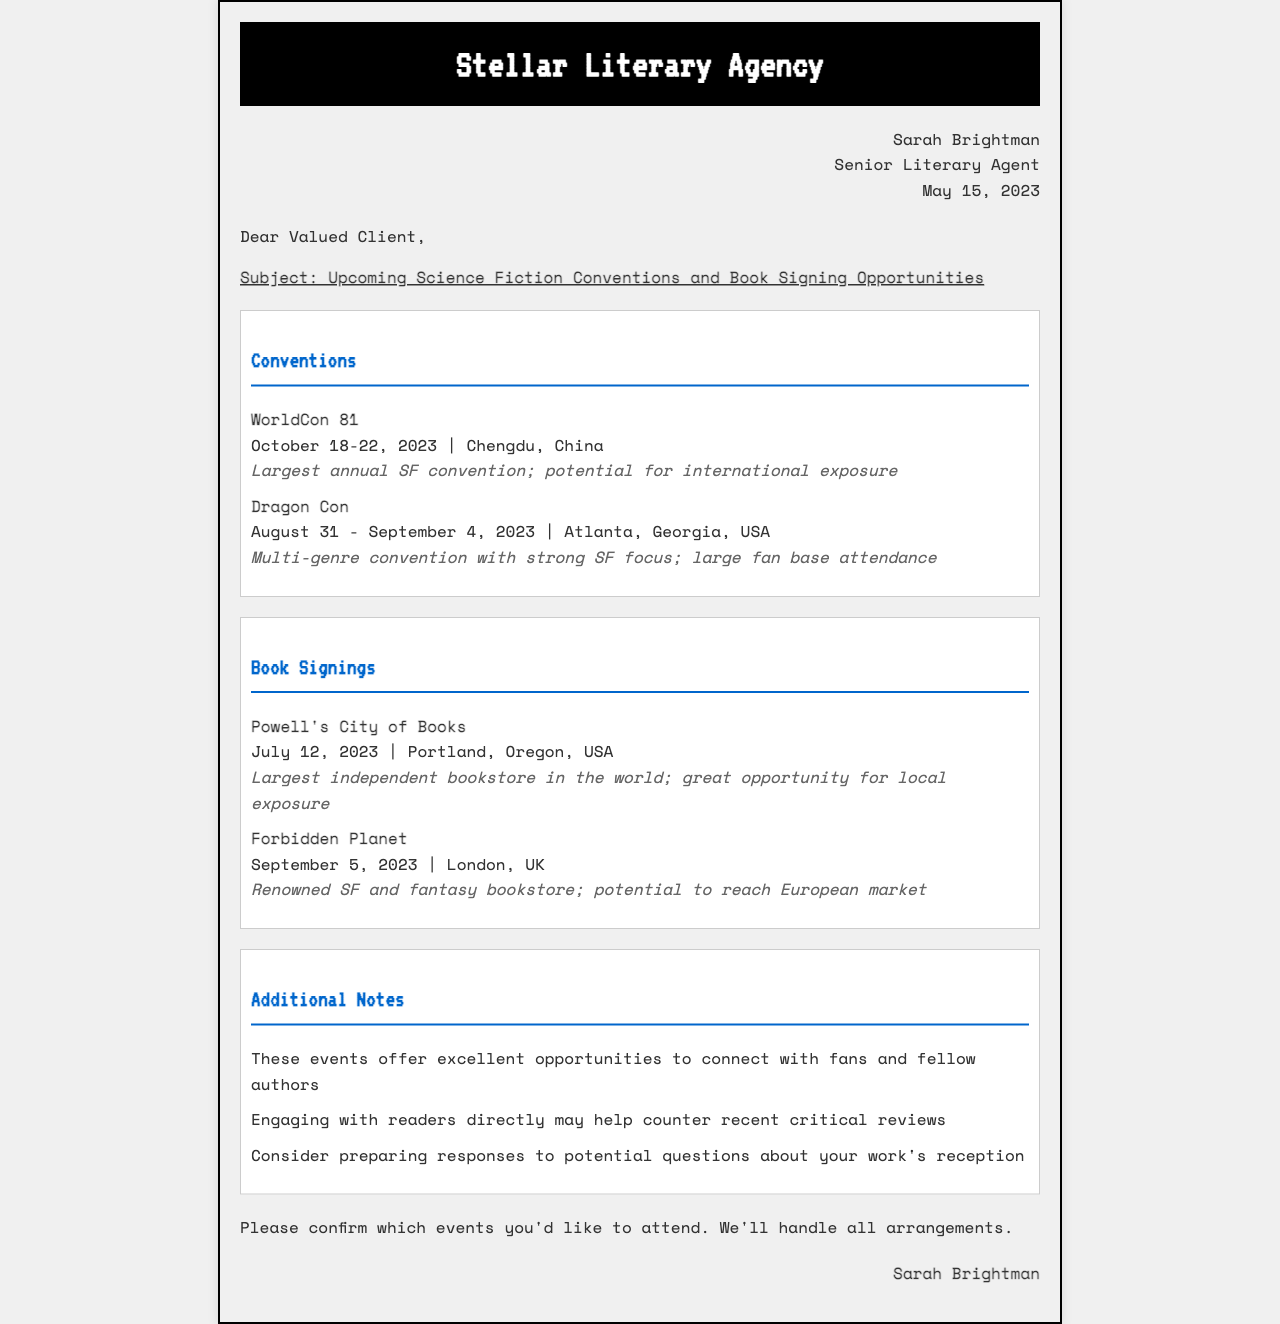What is the name of the literary agency? The name of the literary agency is mentioned in the header of the document.
Answer: Stellar Literary Agency Who is the agent that sent this fax? The agent's name is listed in the agent information section of the document.
Answer: Sarah Brightman When is WorldCon 81 taking place? The date for WorldCon 81 is provided in the conventions section of the document.
Answer: October 18-22, 2023 What location is Dragon Con held in? The location of Dragon Con is specified in the conventions section of the document.
Answer: Atlanta, Georgia, USA What is the date for the book signing at Powell's City of Books? The book signing date is stated in the book signings section of the document.
Answer: July 12, 2023 What is one benefit of attending the conventions and signings? The document mentions several advantages in the additional notes section.
Answer: Connect with fans How many book signings are listed in the document? The number of book signings is calculated based on the listings provided.
Answer: Two What significant opportunity does the document suggest regarding reader engagement? This refers to the potential impact of directly connecting with readers, as mentioned in the additional notes.
Answer: Counter critical reviews Which bookstore is located in London? The bookstore's name is mentioned in the book signings section of the document.
Answer: Forbidden Planet 